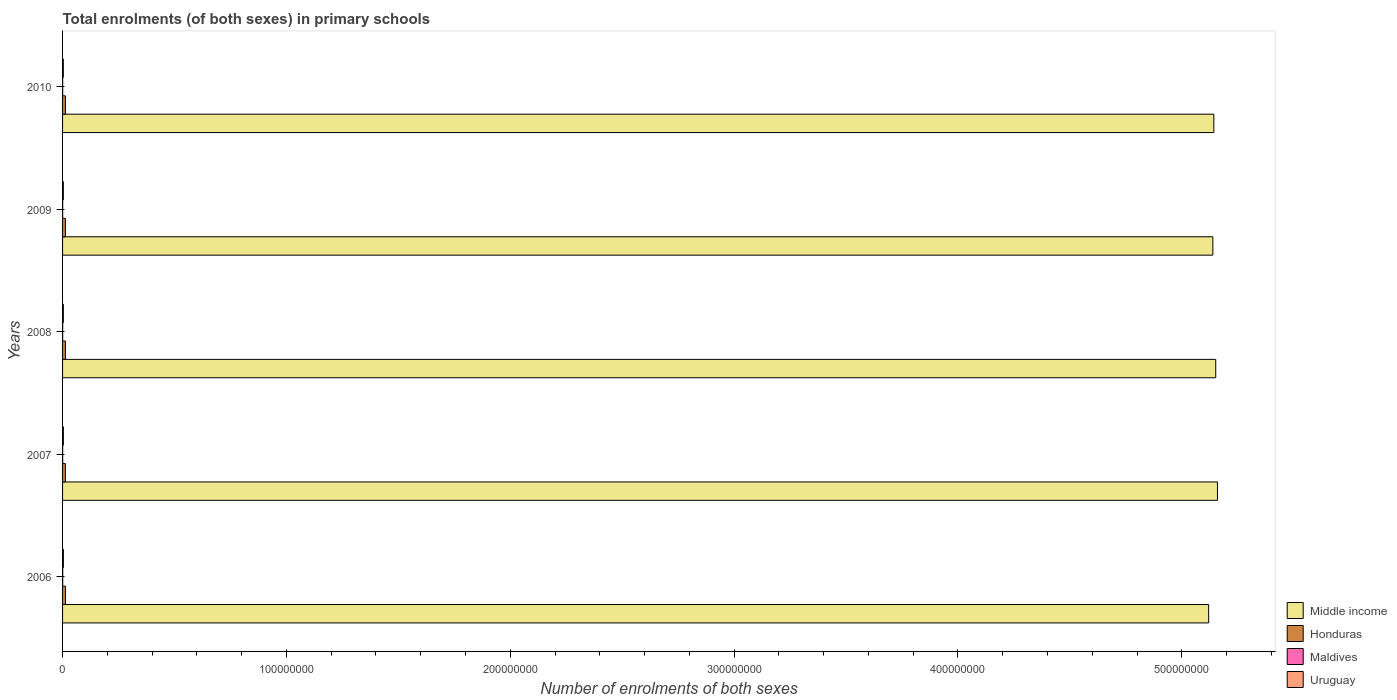How many different coloured bars are there?
Your answer should be very brief. 4. How many groups of bars are there?
Ensure brevity in your answer.  5. Are the number of bars per tick equal to the number of legend labels?
Your answer should be very brief. Yes. How many bars are there on the 3rd tick from the top?
Give a very brief answer. 4. How many bars are there on the 4th tick from the bottom?
Make the answer very short. 4. What is the label of the 5th group of bars from the top?
Your response must be concise. 2006. What is the number of enrolments in primary schools in Honduras in 2008?
Keep it short and to the point. 1.28e+06. Across all years, what is the maximum number of enrolments in primary schools in Maldives?
Make the answer very short. 5.48e+04. Across all years, what is the minimum number of enrolments in primary schools in Maldives?
Give a very brief answer. 4.21e+04. What is the total number of enrolments in primary schools in Middle income in the graph?
Ensure brevity in your answer.  2.57e+09. What is the difference between the number of enrolments in primary schools in Middle income in 2007 and that in 2009?
Provide a succinct answer. 2.05e+06. What is the difference between the number of enrolments in primary schools in Middle income in 2009 and the number of enrolments in primary schools in Uruguay in 2008?
Keep it short and to the point. 5.14e+08. What is the average number of enrolments in primary schools in Honduras per year?
Your answer should be compact. 1.27e+06. In the year 2008, what is the difference between the number of enrolments in primary schools in Maldives and number of enrolments in primary schools in Uruguay?
Keep it short and to the point. -3.06e+05. In how many years, is the number of enrolments in primary schools in Middle income greater than 440000000 ?
Offer a very short reply. 5. What is the ratio of the number of enrolments in primary schools in Maldives in 2007 to that in 2009?
Offer a terse response. 1.13. Is the number of enrolments in primary schools in Middle income in 2009 less than that in 2010?
Ensure brevity in your answer.  Yes. What is the difference between the highest and the second highest number of enrolments in primary schools in Middle income?
Keep it short and to the point. 7.69e+05. What is the difference between the highest and the lowest number of enrolments in primary schools in Middle income?
Give a very brief answer. 3.93e+06. What does the 2nd bar from the top in 2010 represents?
Keep it short and to the point. Maldives. What does the 3rd bar from the bottom in 2007 represents?
Provide a succinct answer. Maldives. Is it the case that in every year, the sum of the number of enrolments in primary schools in Maldives and number of enrolments in primary schools in Honduras is greater than the number of enrolments in primary schools in Middle income?
Keep it short and to the point. No. Are all the bars in the graph horizontal?
Your answer should be very brief. Yes. How many years are there in the graph?
Make the answer very short. 5. Where does the legend appear in the graph?
Provide a short and direct response. Bottom right. How are the legend labels stacked?
Your answer should be compact. Vertical. What is the title of the graph?
Your answer should be very brief. Total enrolments (of both sexes) in primary schools. Does "Tuvalu" appear as one of the legend labels in the graph?
Make the answer very short. No. What is the label or title of the X-axis?
Your answer should be compact. Number of enrolments of both sexes. What is the label or title of the Y-axis?
Your answer should be compact. Years. What is the Number of enrolments of both sexes in Middle income in 2006?
Your response must be concise. 5.12e+08. What is the Number of enrolments of both sexes of Honduras in 2006?
Offer a very short reply. 1.29e+06. What is the Number of enrolments of both sexes in Maldives in 2006?
Your response must be concise. 5.48e+04. What is the Number of enrolments of both sexes in Uruguay in 2006?
Offer a terse response. 3.65e+05. What is the Number of enrolments of both sexes of Middle income in 2007?
Ensure brevity in your answer.  5.16e+08. What is the Number of enrolments of both sexes of Honduras in 2007?
Offer a very short reply. 1.25e+06. What is the Number of enrolments of both sexes of Maldives in 2007?
Ensure brevity in your answer.  5.03e+04. What is the Number of enrolments of both sexes of Uruguay in 2007?
Provide a short and direct response. 3.59e+05. What is the Number of enrolments of both sexes in Middle income in 2008?
Provide a short and direct response. 5.15e+08. What is the Number of enrolments of both sexes in Honduras in 2008?
Your answer should be compact. 1.28e+06. What is the Number of enrolments of both sexes of Maldives in 2008?
Offer a very short reply. 4.71e+04. What is the Number of enrolments of both sexes in Uruguay in 2008?
Keep it short and to the point. 3.54e+05. What is the Number of enrolments of both sexes of Middle income in 2009?
Offer a very short reply. 5.14e+08. What is the Number of enrolments of both sexes in Honduras in 2009?
Your answer should be very brief. 1.27e+06. What is the Number of enrolments of both sexes of Maldives in 2009?
Ensure brevity in your answer.  4.47e+04. What is the Number of enrolments of both sexes of Uruguay in 2009?
Give a very brief answer. 3.49e+05. What is the Number of enrolments of both sexes of Middle income in 2010?
Ensure brevity in your answer.  5.14e+08. What is the Number of enrolments of both sexes in Honduras in 2010?
Give a very brief answer. 1.27e+06. What is the Number of enrolments of both sexes in Maldives in 2010?
Provide a short and direct response. 4.21e+04. What is the Number of enrolments of both sexes in Uruguay in 2010?
Ensure brevity in your answer.  3.42e+05. Across all years, what is the maximum Number of enrolments of both sexes of Middle income?
Make the answer very short. 5.16e+08. Across all years, what is the maximum Number of enrolments of both sexes in Honduras?
Ensure brevity in your answer.  1.29e+06. Across all years, what is the maximum Number of enrolments of both sexes of Maldives?
Provide a succinct answer. 5.48e+04. Across all years, what is the maximum Number of enrolments of both sexes in Uruguay?
Make the answer very short. 3.65e+05. Across all years, what is the minimum Number of enrolments of both sexes in Middle income?
Your answer should be very brief. 5.12e+08. Across all years, what is the minimum Number of enrolments of both sexes of Honduras?
Keep it short and to the point. 1.25e+06. Across all years, what is the minimum Number of enrolments of both sexes of Maldives?
Keep it short and to the point. 4.21e+04. Across all years, what is the minimum Number of enrolments of both sexes in Uruguay?
Your answer should be very brief. 3.42e+05. What is the total Number of enrolments of both sexes in Middle income in the graph?
Offer a very short reply. 2.57e+09. What is the total Number of enrolments of both sexes in Honduras in the graph?
Your answer should be compact. 6.36e+06. What is the total Number of enrolments of both sexes of Maldives in the graph?
Ensure brevity in your answer.  2.39e+05. What is the total Number of enrolments of both sexes of Uruguay in the graph?
Keep it short and to the point. 1.77e+06. What is the difference between the Number of enrolments of both sexes of Middle income in 2006 and that in 2007?
Make the answer very short. -3.93e+06. What is the difference between the Number of enrolments of both sexes of Honduras in 2006 and that in 2007?
Your response must be concise. 4.16e+04. What is the difference between the Number of enrolments of both sexes in Maldives in 2006 and that in 2007?
Keep it short and to the point. 4500. What is the difference between the Number of enrolments of both sexes of Uruguay in 2006 and that in 2007?
Provide a succinct answer. 5949. What is the difference between the Number of enrolments of both sexes of Middle income in 2006 and that in 2008?
Provide a succinct answer. -3.16e+06. What is the difference between the Number of enrolments of both sexes of Honduras in 2006 and that in 2008?
Provide a succinct answer. 1.68e+04. What is the difference between the Number of enrolments of both sexes in Maldives in 2006 and that in 2008?
Your answer should be very brief. 7688. What is the difference between the Number of enrolments of both sexes of Uruguay in 2006 and that in 2008?
Your response must be concise. 1.18e+04. What is the difference between the Number of enrolments of both sexes of Middle income in 2006 and that in 2009?
Your answer should be very brief. -1.87e+06. What is the difference between the Number of enrolments of both sexes of Honduras in 2006 and that in 2009?
Ensure brevity in your answer.  2.74e+04. What is the difference between the Number of enrolments of both sexes of Maldives in 2006 and that in 2009?
Keep it short and to the point. 1.01e+04. What is the difference between the Number of enrolments of both sexes in Uruguay in 2006 and that in 2009?
Give a very brief answer. 1.67e+04. What is the difference between the Number of enrolments of both sexes of Middle income in 2006 and that in 2010?
Provide a succinct answer. -2.31e+06. What is the difference between the Number of enrolments of both sexes of Honduras in 2006 and that in 2010?
Make the answer very short. 1.84e+04. What is the difference between the Number of enrolments of both sexes of Maldives in 2006 and that in 2010?
Your answer should be very brief. 1.26e+04. What is the difference between the Number of enrolments of both sexes of Uruguay in 2006 and that in 2010?
Provide a short and direct response. 2.35e+04. What is the difference between the Number of enrolments of both sexes in Middle income in 2007 and that in 2008?
Your answer should be compact. 7.69e+05. What is the difference between the Number of enrolments of both sexes in Honduras in 2007 and that in 2008?
Offer a very short reply. -2.48e+04. What is the difference between the Number of enrolments of both sexes in Maldives in 2007 and that in 2008?
Ensure brevity in your answer.  3188. What is the difference between the Number of enrolments of both sexes of Uruguay in 2007 and that in 2008?
Provide a succinct answer. 5879. What is the difference between the Number of enrolments of both sexes of Middle income in 2007 and that in 2009?
Your response must be concise. 2.05e+06. What is the difference between the Number of enrolments of both sexes of Honduras in 2007 and that in 2009?
Your answer should be compact. -1.42e+04. What is the difference between the Number of enrolments of both sexes of Maldives in 2007 and that in 2009?
Provide a succinct answer. 5595. What is the difference between the Number of enrolments of both sexes of Uruguay in 2007 and that in 2009?
Your answer should be very brief. 1.07e+04. What is the difference between the Number of enrolments of both sexes of Middle income in 2007 and that in 2010?
Your answer should be compact. 1.61e+06. What is the difference between the Number of enrolments of both sexes in Honduras in 2007 and that in 2010?
Provide a short and direct response. -2.32e+04. What is the difference between the Number of enrolments of both sexes of Maldives in 2007 and that in 2010?
Ensure brevity in your answer.  8124. What is the difference between the Number of enrolments of both sexes in Uruguay in 2007 and that in 2010?
Offer a very short reply. 1.76e+04. What is the difference between the Number of enrolments of both sexes in Middle income in 2008 and that in 2009?
Offer a terse response. 1.28e+06. What is the difference between the Number of enrolments of both sexes of Honduras in 2008 and that in 2009?
Your answer should be very brief. 1.05e+04. What is the difference between the Number of enrolments of both sexes in Maldives in 2008 and that in 2009?
Offer a very short reply. 2407. What is the difference between the Number of enrolments of both sexes in Uruguay in 2008 and that in 2009?
Offer a terse response. 4869. What is the difference between the Number of enrolments of both sexes in Middle income in 2008 and that in 2010?
Your answer should be very brief. 8.45e+05. What is the difference between the Number of enrolments of both sexes in Honduras in 2008 and that in 2010?
Make the answer very short. 1591. What is the difference between the Number of enrolments of both sexes of Maldives in 2008 and that in 2010?
Keep it short and to the point. 4936. What is the difference between the Number of enrolments of both sexes of Uruguay in 2008 and that in 2010?
Provide a short and direct response. 1.17e+04. What is the difference between the Number of enrolments of both sexes in Middle income in 2009 and that in 2010?
Make the answer very short. -4.38e+05. What is the difference between the Number of enrolments of both sexes of Honduras in 2009 and that in 2010?
Offer a terse response. -8941. What is the difference between the Number of enrolments of both sexes in Maldives in 2009 and that in 2010?
Ensure brevity in your answer.  2529. What is the difference between the Number of enrolments of both sexes of Uruguay in 2009 and that in 2010?
Give a very brief answer. 6806. What is the difference between the Number of enrolments of both sexes in Middle income in 2006 and the Number of enrolments of both sexes in Honduras in 2007?
Make the answer very short. 5.11e+08. What is the difference between the Number of enrolments of both sexes in Middle income in 2006 and the Number of enrolments of both sexes in Maldives in 2007?
Offer a very short reply. 5.12e+08. What is the difference between the Number of enrolments of both sexes of Middle income in 2006 and the Number of enrolments of both sexes of Uruguay in 2007?
Your response must be concise. 5.12e+08. What is the difference between the Number of enrolments of both sexes in Honduras in 2006 and the Number of enrolments of both sexes in Maldives in 2007?
Make the answer very short. 1.24e+06. What is the difference between the Number of enrolments of both sexes of Honduras in 2006 and the Number of enrolments of both sexes of Uruguay in 2007?
Your response must be concise. 9.34e+05. What is the difference between the Number of enrolments of both sexes of Maldives in 2006 and the Number of enrolments of both sexes of Uruguay in 2007?
Provide a short and direct response. -3.05e+05. What is the difference between the Number of enrolments of both sexes in Middle income in 2006 and the Number of enrolments of both sexes in Honduras in 2008?
Offer a very short reply. 5.11e+08. What is the difference between the Number of enrolments of both sexes in Middle income in 2006 and the Number of enrolments of both sexes in Maldives in 2008?
Your answer should be very brief. 5.12e+08. What is the difference between the Number of enrolments of both sexes in Middle income in 2006 and the Number of enrolments of both sexes in Uruguay in 2008?
Your answer should be very brief. 5.12e+08. What is the difference between the Number of enrolments of both sexes in Honduras in 2006 and the Number of enrolments of both sexes in Maldives in 2008?
Make the answer very short. 1.25e+06. What is the difference between the Number of enrolments of both sexes in Honduras in 2006 and the Number of enrolments of both sexes in Uruguay in 2008?
Your answer should be very brief. 9.40e+05. What is the difference between the Number of enrolments of both sexes of Maldives in 2006 and the Number of enrolments of both sexes of Uruguay in 2008?
Offer a very short reply. -2.99e+05. What is the difference between the Number of enrolments of both sexes of Middle income in 2006 and the Number of enrolments of both sexes of Honduras in 2009?
Your response must be concise. 5.11e+08. What is the difference between the Number of enrolments of both sexes of Middle income in 2006 and the Number of enrolments of both sexes of Maldives in 2009?
Make the answer very short. 5.12e+08. What is the difference between the Number of enrolments of both sexes of Middle income in 2006 and the Number of enrolments of both sexes of Uruguay in 2009?
Ensure brevity in your answer.  5.12e+08. What is the difference between the Number of enrolments of both sexes of Honduras in 2006 and the Number of enrolments of both sexes of Maldives in 2009?
Provide a succinct answer. 1.25e+06. What is the difference between the Number of enrolments of both sexes of Honduras in 2006 and the Number of enrolments of both sexes of Uruguay in 2009?
Keep it short and to the point. 9.45e+05. What is the difference between the Number of enrolments of both sexes of Maldives in 2006 and the Number of enrolments of both sexes of Uruguay in 2009?
Offer a terse response. -2.94e+05. What is the difference between the Number of enrolments of both sexes of Middle income in 2006 and the Number of enrolments of both sexes of Honduras in 2010?
Offer a very short reply. 5.11e+08. What is the difference between the Number of enrolments of both sexes of Middle income in 2006 and the Number of enrolments of both sexes of Maldives in 2010?
Provide a short and direct response. 5.12e+08. What is the difference between the Number of enrolments of both sexes of Middle income in 2006 and the Number of enrolments of both sexes of Uruguay in 2010?
Give a very brief answer. 5.12e+08. What is the difference between the Number of enrolments of both sexes in Honduras in 2006 and the Number of enrolments of both sexes in Maldives in 2010?
Your answer should be very brief. 1.25e+06. What is the difference between the Number of enrolments of both sexes of Honduras in 2006 and the Number of enrolments of both sexes of Uruguay in 2010?
Provide a succinct answer. 9.51e+05. What is the difference between the Number of enrolments of both sexes in Maldives in 2006 and the Number of enrolments of both sexes in Uruguay in 2010?
Your answer should be compact. -2.87e+05. What is the difference between the Number of enrolments of both sexes of Middle income in 2007 and the Number of enrolments of both sexes of Honduras in 2008?
Provide a succinct answer. 5.15e+08. What is the difference between the Number of enrolments of both sexes in Middle income in 2007 and the Number of enrolments of both sexes in Maldives in 2008?
Give a very brief answer. 5.16e+08. What is the difference between the Number of enrolments of both sexes in Middle income in 2007 and the Number of enrolments of both sexes in Uruguay in 2008?
Offer a very short reply. 5.16e+08. What is the difference between the Number of enrolments of both sexes in Honduras in 2007 and the Number of enrolments of both sexes in Maldives in 2008?
Keep it short and to the point. 1.20e+06. What is the difference between the Number of enrolments of both sexes of Honduras in 2007 and the Number of enrolments of both sexes of Uruguay in 2008?
Provide a succinct answer. 8.98e+05. What is the difference between the Number of enrolments of both sexes of Maldives in 2007 and the Number of enrolments of both sexes of Uruguay in 2008?
Ensure brevity in your answer.  -3.03e+05. What is the difference between the Number of enrolments of both sexes in Middle income in 2007 and the Number of enrolments of both sexes in Honduras in 2009?
Your response must be concise. 5.15e+08. What is the difference between the Number of enrolments of both sexes in Middle income in 2007 and the Number of enrolments of both sexes in Maldives in 2009?
Give a very brief answer. 5.16e+08. What is the difference between the Number of enrolments of both sexes of Middle income in 2007 and the Number of enrolments of both sexes of Uruguay in 2009?
Make the answer very short. 5.16e+08. What is the difference between the Number of enrolments of both sexes of Honduras in 2007 and the Number of enrolments of both sexes of Maldives in 2009?
Provide a succinct answer. 1.21e+06. What is the difference between the Number of enrolments of both sexes of Honduras in 2007 and the Number of enrolments of both sexes of Uruguay in 2009?
Provide a short and direct response. 9.03e+05. What is the difference between the Number of enrolments of both sexes of Maldives in 2007 and the Number of enrolments of both sexes of Uruguay in 2009?
Keep it short and to the point. -2.98e+05. What is the difference between the Number of enrolments of both sexes in Middle income in 2007 and the Number of enrolments of both sexes in Honduras in 2010?
Your answer should be compact. 5.15e+08. What is the difference between the Number of enrolments of both sexes in Middle income in 2007 and the Number of enrolments of both sexes in Maldives in 2010?
Provide a short and direct response. 5.16e+08. What is the difference between the Number of enrolments of both sexes of Middle income in 2007 and the Number of enrolments of both sexes of Uruguay in 2010?
Ensure brevity in your answer.  5.16e+08. What is the difference between the Number of enrolments of both sexes in Honduras in 2007 and the Number of enrolments of both sexes in Maldives in 2010?
Offer a terse response. 1.21e+06. What is the difference between the Number of enrolments of both sexes in Honduras in 2007 and the Number of enrolments of both sexes in Uruguay in 2010?
Give a very brief answer. 9.10e+05. What is the difference between the Number of enrolments of both sexes in Maldives in 2007 and the Number of enrolments of both sexes in Uruguay in 2010?
Make the answer very short. -2.92e+05. What is the difference between the Number of enrolments of both sexes of Middle income in 2008 and the Number of enrolments of both sexes of Honduras in 2009?
Ensure brevity in your answer.  5.14e+08. What is the difference between the Number of enrolments of both sexes of Middle income in 2008 and the Number of enrolments of both sexes of Maldives in 2009?
Your response must be concise. 5.15e+08. What is the difference between the Number of enrolments of both sexes in Middle income in 2008 and the Number of enrolments of both sexes in Uruguay in 2009?
Make the answer very short. 5.15e+08. What is the difference between the Number of enrolments of both sexes in Honduras in 2008 and the Number of enrolments of both sexes in Maldives in 2009?
Offer a very short reply. 1.23e+06. What is the difference between the Number of enrolments of both sexes in Honduras in 2008 and the Number of enrolments of both sexes in Uruguay in 2009?
Your response must be concise. 9.28e+05. What is the difference between the Number of enrolments of both sexes in Maldives in 2008 and the Number of enrolments of both sexes in Uruguay in 2009?
Ensure brevity in your answer.  -3.02e+05. What is the difference between the Number of enrolments of both sexes of Middle income in 2008 and the Number of enrolments of both sexes of Honduras in 2010?
Keep it short and to the point. 5.14e+08. What is the difference between the Number of enrolments of both sexes in Middle income in 2008 and the Number of enrolments of both sexes in Maldives in 2010?
Ensure brevity in your answer.  5.15e+08. What is the difference between the Number of enrolments of both sexes of Middle income in 2008 and the Number of enrolments of both sexes of Uruguay in 2010?
Offer a very short reply. 5.15e+08. What is the difference between the Number of enrolments of both sexes in Honduras in 2008 and the Number of enrolments of both sexes in Maldives in 2010?
Your answer should be compact. 1.23e+06. What is the difference between the Number of enrolments of both sexes in Honduras in 2008 and the Number of enrolments of both sexes in Uruguay in 2010?
Your answer should be compact. 9.35e+05. What is the difference between the Number of enrolments of both sexes in Maldives in 2008 and the Number of enrolments of both sexes in Uruguay in 2010?
Make the answer very short. -2.95e+05. What is the difference between the Number of enrolments of both sexes of Middle income in 2009 and the Number of enrolments of both sexes of Honduras in 2010?
Your answer should be very brief. 5.13e+08. What is the difference between the Number of enrolments of both sexes in Middle income in 2009 and the Number of enrolments of both sexes in Maldives in 2010?
Offer a very short reply. 5.14e+08. What is the difference between the Number of enrolments of both sexes in Middle income in 2009 and the Number of enrolments of both sexes in Uruguay in 2010?
Your answer should be very brief. 5.14e+08. What is the difference between the Number of enrolments of both sexes of Honduras in 2009 and the Number of enrolments of both sexes of Maldives in 2010?
Give a very brief answer. 1.22e+06. What is the difference between the Number of enrolments of both sexes in Honduras in 2009 and the Number of enrolments of both sexes in Uruguay in 2010?
Your response must be concise. 9.24e+05. What is the difference between the Number of enrolments of both sexes of Maldives in 2009 and the Number of enrolments of both sexes of Uruguay in 2010?
Provide a succinct answer. -2.97e+05. What is the average Number of enrolments of both sexes in Middle income per year?
Keep it short and to the point. 5.14e+08. What is the average Number of enrolments of both sexes in Honduras per year?
Offer a very short reply. 1.27e+06. What is the average Number of enrolments of both sexes of Maldives per year?
Provide a succinct answer. 4.78e+04. What is the average Number of enrolments of both sexes in Uruguay per year?
Your answer should be compact. 3.54e+05. In the year 2006, what is the difference between the Number of enrolments of both sexes of Middle income and Number of enrolments of both sexes of Honduras?
Offer a very short reply. 5.11e+08. In the year 2006, what is the difference between the Number of enrolments of both sexes of Middle income and Number of enrolments of both sexes of Maldives?
Provide a short and direct response. 5.12e+08. In the year 2006, what is the difference between the Number of enrolments of both sexes in Middle income and Number of enrolments of both sexes in Uruguay?
Provide a short and direct response. 5.12e+08. In the year 2006, what is the difference between the Number of enrolments of both sexes in Honduras and Number of enrolments of both sexes in Maldives?
Offer a terse response. 1.24e+06. In the year 2006, what is the difference between the Number of enrolments of both sexes of Honduras and Number of enrolments of both sexes of Uruguay?
Your answer should be very brief. 9.28e+05. In the year 2006, what is the difference between the Number of enrolments of both sexes in Maldives and Number of enrolments of both sexes in Uruguay?
Your response must be concise. -3.11e+05. In the year 2007, what is the difference between the Number of enrolments of both sexes of Middle income and Number of enrolments of both sexes of Honduras?
Ensure brevity in your answer.  5.15e+08. In the year 2007, what is the difference between the Number of enrolments of both sexes of Middle income and Number of enrolments of both sexes of Maldives?
Your response must be concise. 5.16e+08. In the year 2007, what is the difference between the Number of enrolments of both sexes of Middle income and Number of enrolments of both sexes of Uruguay?
Give a very brief answer. 5.16e+08. In the year 2007, what is the difference between the Number of enrolments of both sexes of Honduras and Number of enrolments of both sexes of Maldives?
Offer a very short reply. 1.20e+06. In the year 2007, what is the difference between the Number of enrolments of both sexes in Honduras and Number of enrolments of both sexes in Uruguay?
Make the answer very short. 8.92e+05. In the year 2007, what is the difference between the Number of enrolments of both sexes in Maldives and Number of enrolments of both sexes in Uruguay?
Your answer should be very brief. -3.09e+05. In the year 2008, what is the difference between the Number of enrolments of both sexes of Middle income and Number of enrolments of both sexes of Honduras?
Your answer should be very brief. 5.14e+08. In the year 2008, what is the difference between the Number of enrolments of both sexes in Middle income and Number of enrolments of both sexes in Maldives?
Keep it short and to the point. 5.15e+08. In the year 2008, what is the difference between the Number of enrolments of both sexes of Middle income and Number of enrolments of both sexes of Uruguay?
Offer a very short reply. 5.15e+08. In the year 2008, what is the difference between the Number of enrolments of both sexes of Honduras and Number of enrolments of both sexes of Maldives?
Provide a succinct answer. 1.23e+06. In the year 2008, what is the difference between the Number of enrolments of both sexes of Honduras and Number of enrolments of both sexes of Uruguay?
Offer a very short reply. 9.23e+05. In the year 2008, what is the difference between the Number of enrolments of both sexes in Maldives and Number of enrolments of both sexes in Uruguay?
Your answer should be compact. -3.06e+05. In the year 2009, what is the difference between the Number of enrolments of both sexes of Middle income and Number of enrolments of both sexes of Honduras?
Give a very brief answer. 5.13e+08. In the year 2009, what is the difference between the Number of enrolments of both sexes in Middle income and Number of enrolments of both sexes in Maldives?
Offer a very short reply. 5.14e+08. In the year 2009, what is the difference between the Number of enrolments of both sexes of Middle income and Number of enrolments of both sexes of Uruguay?
Your response must be concise. 5.14e+08. In the year 2009, what is the difference between the Number of enrolments of both sexes in Honduras and Number of enrolments of both sexes in Maldives?
Make the answer very short. 1.22e+06. In the year 2009, what is the difference between the Number of enrolments of both sexes of Honduras and Number of enrolments of both sexes of Uruguay?
Offer a terse response. 9.17e+05. In the year 2009, what is the difference between the Number of enrolments of both sexes in Maldives and Number of enrolments of both sexes in Uruguay?
Offer a terse response. -3.04e+05. In the year 2010, what is the difference between the Number of enrolments of both sexes in Middle income and Number of enrolments of both sexes in Honduras?
Keep it short and to the point. 5.13e+08. In the year 2010, what is the difference between the Number of enrolments of both sexes of Middle income and Number of enrolments of both sexes of Maldives?
Offer a terse response. 5.14e+08. In the year 2010, what is the difference between the Number of enrolments of both sexes of Middle income and Number of enrolments of both sexes of Uruguay?
Offer a terse response. 5.14e+08. In the year 2010, what is the difference between the Number of enrolments of both sexes of Honduras and Number of enrolments of both sexes of Maldives?
Offer a very short reply. 1.23e+06. In the year 2010, what is the difference between the Number of enrolments of both sexes in Honduras and Number of enrolments of both sexes in Uruguay?
Your answer should be compact. 9.33e+05. In the year 2010, what is the difference between the Number of enrolments of both sexes in Maldives and Number of enrolments of both sexes in Uruguay?
Your answer should be compact. -3.00e+05. What is the ratio of the Number of enrolments of both sexes of Honduras in 2006 to that in 2007?
Provide a succinct answer. 1.03. What is the ratio of the Number of enrolments of both sexes in Maldives in 2006 to that in 2007?
Your answer should be very brief. 1.09. What is the ratio of the Number of enrolments of both sexes in Uruguay in 2006 to that in 2007?
Give a very brief answer. 1.02. What is the ratio of the Number of enrolments of both sexes in Honduras in 2006 to that in 2008?
Offer a terse response. 1.01. What is the ratio of the Number of enrolments of both sexes of Maldives in 2006 to that in 2008?
Give a very brief answer. 1.16. What is the ratio of the Number of enrolments of both sexes in Uruguay in 2006 to that in 2008?
Keep it short and to the point. 1.03. What is the ratio of the Number of enrolments of both sexes of Honduras in 2006 to that in 2009?
Your response must be concise. 1.02. What is the ratio of the Number of enrolments of both sexes in Maldives in 2006 to that in 2009?
Your response must be concise. 1.23. What is the ratio of the Number of enrolments of both sexes in Uruguay in 2006 to that in 2009?
Your response must be concise. 1.05. What is the ratio of the Number of enrolments of both sexes of Middle income in 2006 to that in 2010?
Your answer should be very brief. 1. What is the ratio of the Number of enrolments of both sexes of Honduras in 2006 to that in 2010?
Provide a short and direct response. 1.01. What is the ratio of the Number of enrolments of both sexes of Maldives in 2006 to that in 2010?
Your answer should be compact. 1.3. What is the ratio of the Number of enrolments of both sexes in Uruguay in 2006 to that in 2010?
Offer a very short reply. 1.07. What is the ratio of the Number of enrolments of both sexes in Middle income in 2007 to that in 2008?
Offer a terse response. 1. What is the ratio of the Number of enrolments of both sexes of Honduras in 2007 to that in 2008?
Offer a very short reply. 0.98. What is the ratio of the Number of enrolments of both sexes in Maldives in 2007 to that in 2008?
Offer a terse response. 1.07. What is the ratio of the Number of enrolments of both sexes of Uruguay in 2007 to that in 2008?
Ensure brevity in your answer.  1.02. What is the ratio of the Number of enrolments of both sexes of Middle income in 2007 to that in 2009?
Make the answer very short. 1. What is the ratio of the Number of enrolments of both sexes in Honduras in 2007 to that in 2009?
Offer a very short reply. 0.99. What is the ratio of the Number of enrolments of both sexes of Maldives in 2007 to that in 2009?
Offer a terse response. 1.13. What is the ratio of the Number of enrolments of both sexes in Uruguay in 2007 to that in 2009?
Provide a succinct answer. 1.03. What is the ratio of the Number of enrolments of both sexes in Honduras in 2007 to that in 2010?
Give a very brief answer. 0.98. What is the ratio of the Number of enrolments of both sexes in Maldives in 2007 to that in 2010?
Provide a succinct answer. 1.19. What is the ratio of the Number of enrolments of both sexes in Uruguay in 2007 to that in 2010?
Provide a short and direct response. 1.05. What is the ratio of the Number of enrolments of both sexes of Middle income in 2008 to that in 2009?
Offer a very short reply. 1. What is the ratio of the Number of enrolments of both sexes in Honduras in 2008 to that in 2009?
Offer a very short reply. 1.01. What is the ratio of the Number of enrolments of both sexes in Maldives in 2008 to that in 2009?
Offer a very short reply. 1.05. What is the ratio of the Number of enrolments of both sexes in Uruguay in 2008 to that in 2009?
Your response must be concise. 1.01. What is the ratio of the Number of enrolments of both sexes in Maldives in 2008 to that in 2010?
Your answer should be very brief. 1.12. What is the ratio of the Number of enrolments of both sexes in Uruguay in 2008 to that in 2010?
Give a very brief answer. 1.03. What is the ratio of the Number of enrolments of both sexes in Middle income in 2009 to that in 2010?
Your answer should be very brief. 1. What is the ratio of the Number of enrolments of both sexes of Honduras in 2009 to that in 2010?
Make the answer very short. 0.99. What is the ratio of the Number of enrolments of both sexes in Maldives in 2009 to that in 2010?
Provide a succinct answer. 1.06. What is the ratio of the Number of enrolments of both sexes in Uruguay in 2009 to that in 2010?
Provide a short and direct response. 1.02. What is the difference between the highest and the second highest Number of enrolments of both sexes of Middle income?
Offer a terse response. 7.69e+05. What is the difference between the highest and the second highest Number of enrolments of both sexes in Honduras?
Your response must be concise. 1.68e+04. What is the difference between the highest and the second highest Number of enrolments of both sexes in Maldives?
Provide a short and direct response. 4500. What is the difference between the highest and the second highest Number of enrolments of both sexes of Uruguay?
Your response must be concise. 5949. What is the difference between the highest and the lowest Number of enrolments of both sexes of Middle income?
Your response must be concise. 3.93e+06. What is the difference between the highest and the lowest Number of enrolments of both sexes of Honduras?
Offer a terse response. 4.16e+04. What is the difference between the highest and the lowest Number of enrolments of both sexes of Maldives?
Offer a very short reply. 1.26e+04. What is the difference between the highest and the lowest Number of enrolments of both sexes in Uruguay?
Offer a terse response. 2.35e+04. 